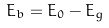<formula> <loc_0><loc_0><loc_500><loc_500>E _ { b } = E _ { 0 } - E _ { g }</formula> 